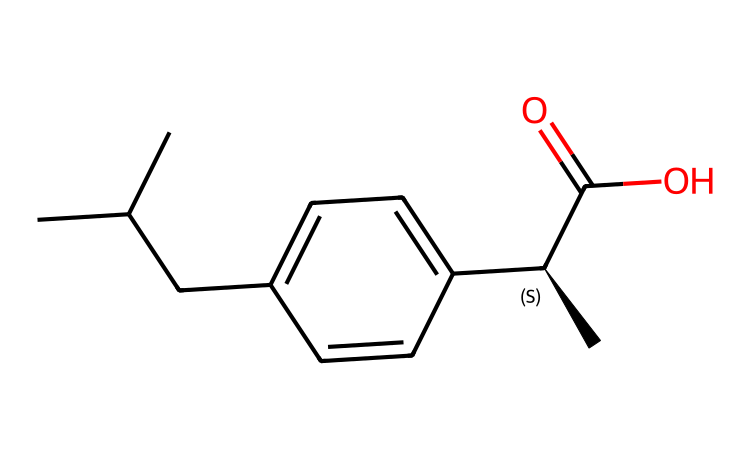What is the molecular formula of ibuprofen? By analyzing the SMILES representation, we identify the atoms present in the structure: 13 carbon (C) atoms, 18 hydrogen (H) atoms, and 2 oxygen (O) atoms, leading us to the formula C13H18O2.
Answer: C13H18O2 How many rings does ibuprofen have in its structure? The SMILES representation does not display any cyclic sections or denote aromatic rings. Observing the structure's layout, it indicates that ibuprofen is a linear molecule without any rings.
Answer: 0 What is the functional group present in ibuprofen? The SMILES indicates a carboxylic acid functional group (C(=O)O), characterized by a carbon atom double-bonded to oxygen and single-bonded to a hydroxyl group (OH), confirming this as the functional group in ibuprofen.
Answer: carboxylic acid Which specific stereoisomer is represented in ibuprofen's SMILES? The '@' symbol in the SMILES refers to the presence of a chiral center, indicating that this representation corresponds to the S-enantiomer (commonly referred to as the natural form), which offers the desired anti-inflammatory effects.
Answer: S-enantiomer How many total bonds can be found in ibuprofen? Counting the different types of bonds represented in the SMILES: we see multiple single (C-C) and double (C=O) bonds. After analyzing the structure carefully, we can find a total of 16 bonds throughout the molecule.
Answer: 16 What type of medicinal action does ibuprofen primarily exert? Based on its molecular structure and functional groups, ibuprofen is known to primarily exert anti-inflammatory effects by inhibiting cyclooxygenase enzymes, providing relief from pain and inflammation.
Answer: anti-inflammatory 